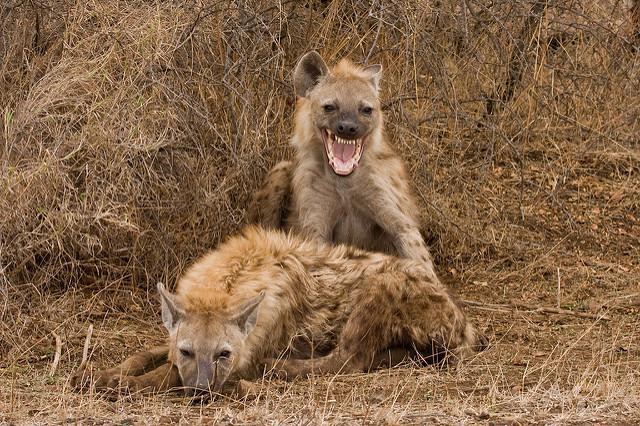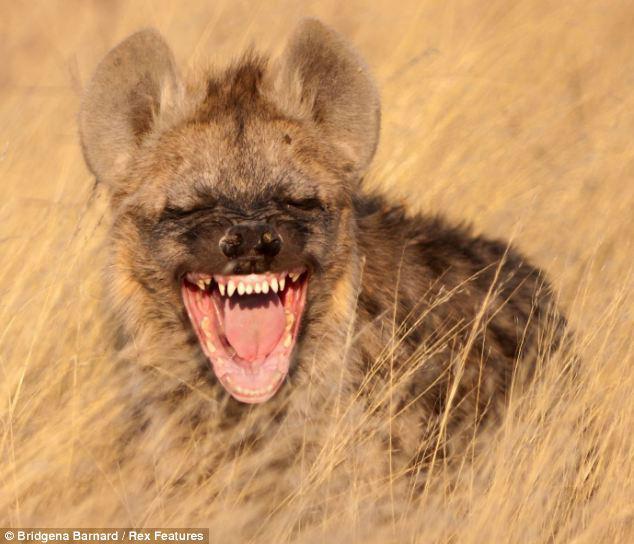The first image is the image on the left, the second image is the image on the right. Considering the images on both sides, is "Each image includes a hyena with a wide open mouth." valid? Answer yes or no. Yes. The first image is the image on the left, the second image is the image on the right. Given the left and right images, does the statement "Two hyenas have their mouths open." hold true? Answer yes or no. Yes. 